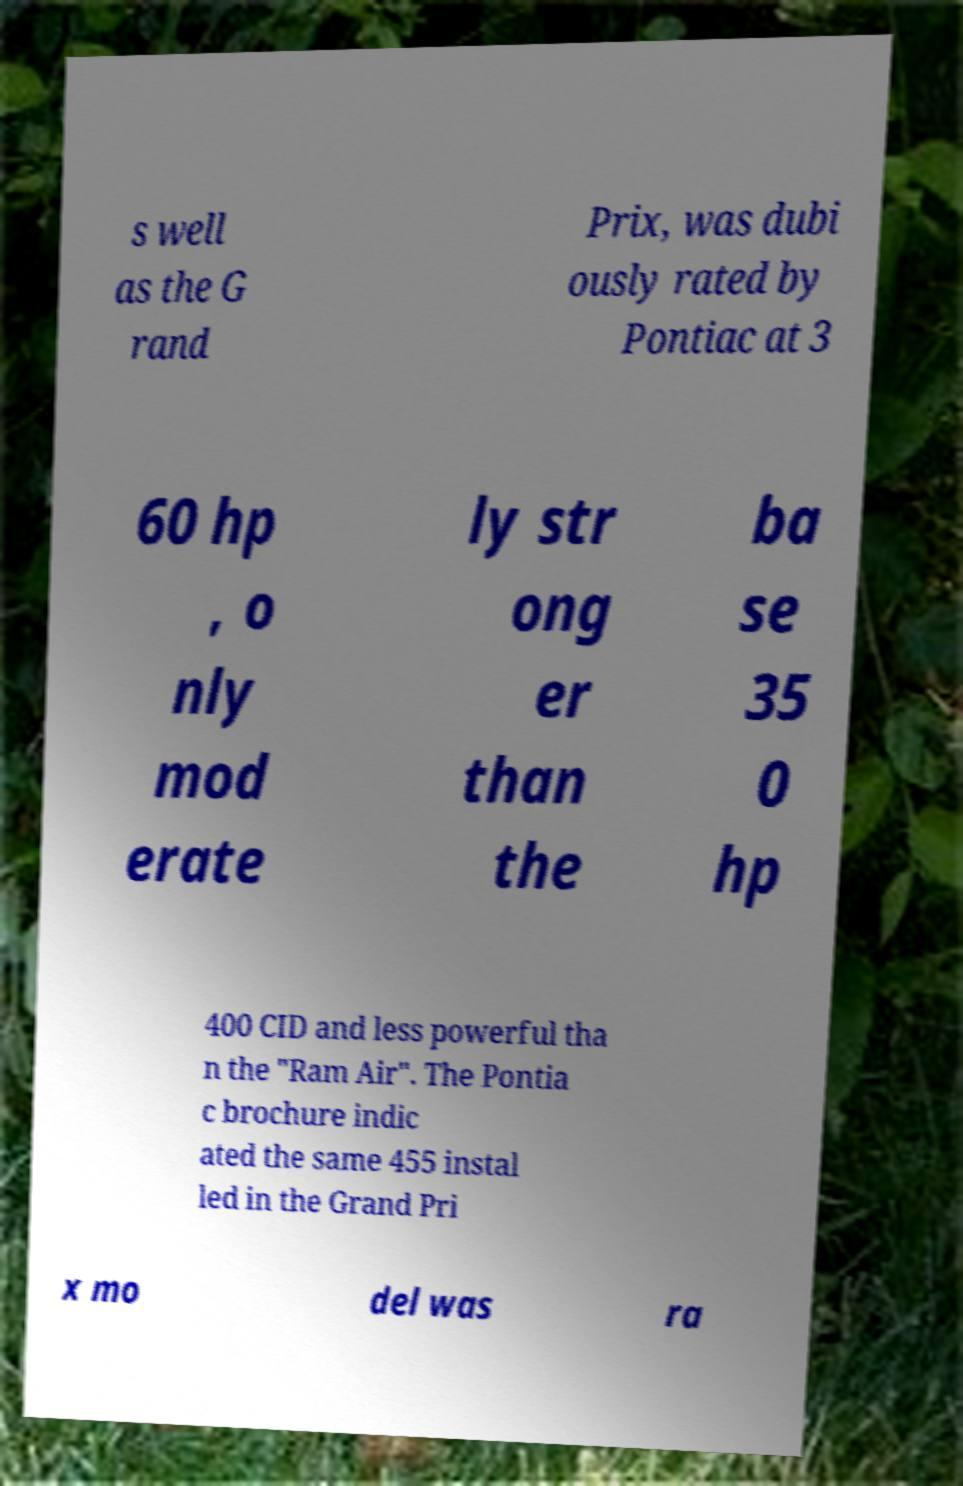What messages or text are displayed in this image? I need them in a readable, typed format. s well as the G rand Prix, was dubi ously rated by Pontiac at 3 60 hp , o nly mod erate ly str ong er than the ba se 35 0 hp 400 CID and less powerful tha n the "Ram Air". The Pontia c brochure indic ated the same 455 instal led in the Grand Pri x mo del was ra 